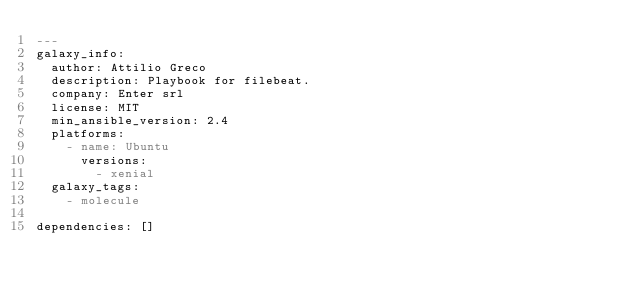Convert code to text. <code><loc_0><loc_0><loc_500><loc_500><_YAML_>---
galaxy_info:
  author: Attilio Greco
  description: Playbook for filebeat.
  company: Enter srl
  license: MIT
  min_ansible_version: 2.4
  platforms:
    - name: Ubuntu
      versions:
        - xenial
  galaxy_tags:
    - molecule

dependencies: []
</code> 